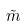<formula> <loc_0><loc_0><loc_500><loc_500>\tilde { m }</formula> 